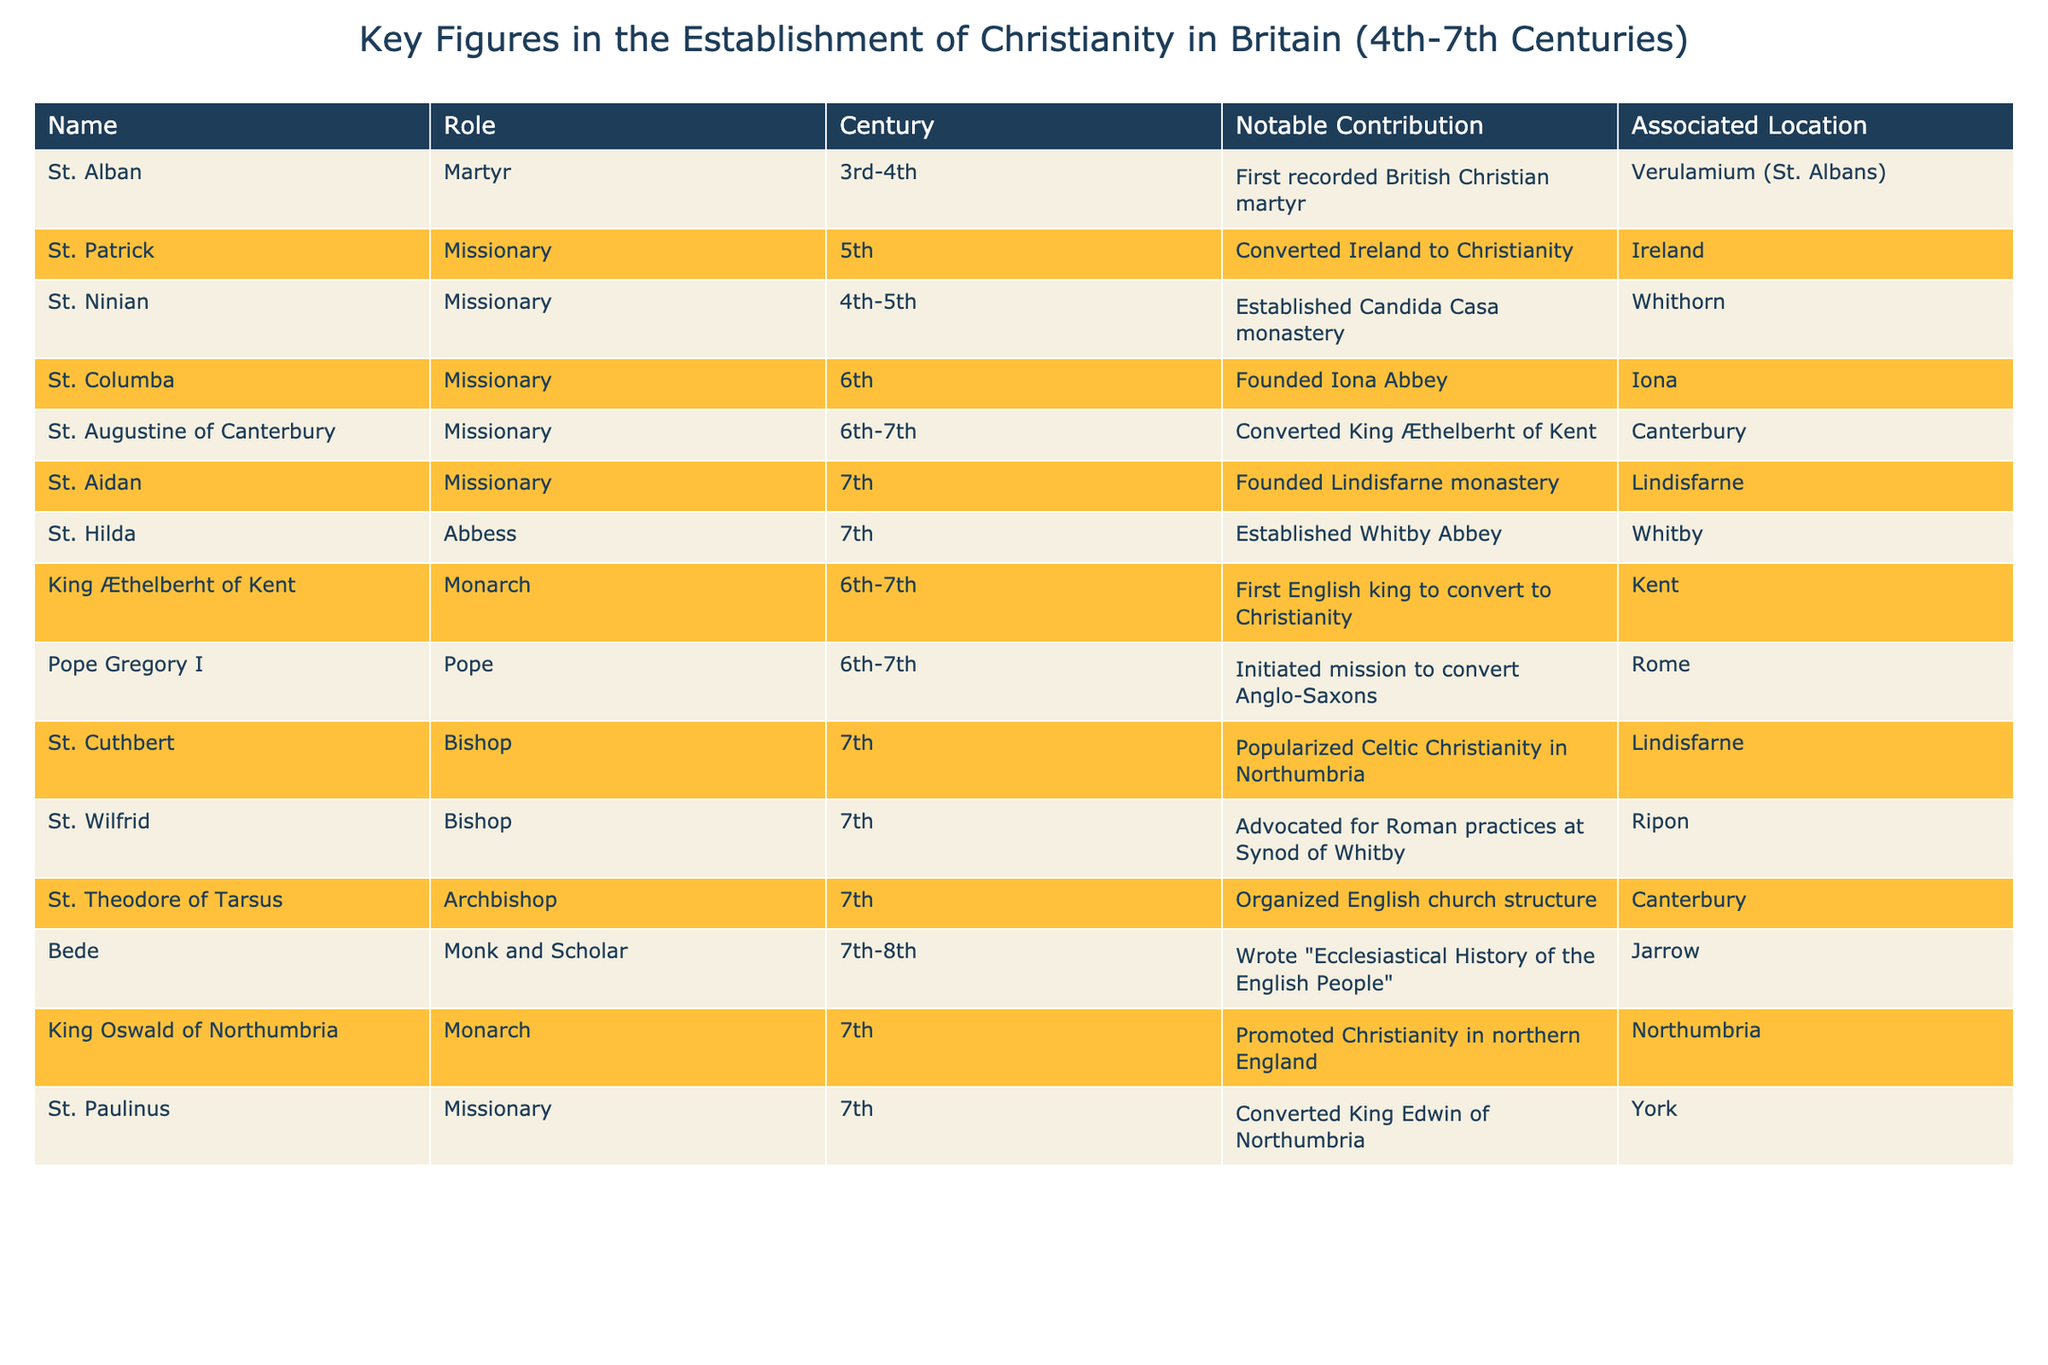What was St. Alban's notable contribution? St. Alban is recorded in the table as the first British Christian martyr. This specific information can be found in the "Notable Contribution" column associated with his name.
Answer: First recorded British Christian martyr Which century did St. Augustine of Canterbury contribute to the establishment of Christianity in Britain? By referencing the "Century" column in the table next to St. Augustine of Canterbury's name, we find that his contributions occurred during the 6th-7th centuries.
Answer: 6th-7th century How many figures in the table were involved in missionary work? By reviewing the roles listed in the table, we count those identified as "Missionary." There are 6 individuals fulfilling this role: St. Patrick, St. Ninian, St. Columba, St. Augustine of Canterbury, St. Aidan, and St. Paulinus.
Answer: 6 Did any of the key figures have a significant role in converting a king to Christianity? By examining the data, we find that both St. Augustine of Canterbury and St. Paulinus are noted for converting kings (King Æthelberht of Kent and King Edwin of Northumbria, respectively). Therefore, the answer is yes.
Answer: Yes Who was the first English king to convert to Christianity? Looking at the "Notable Contribution" for King Æthelberht of Kent in the table, it states that he was the first English king to convert to Christianity, indicating his significance in this matter.
Answer: King Æthelberht of Kent What is the average century of the key figures listed in the table? To find the average century, we convert the centuries into numerical values (taking 6th-7th as 6.5 and averaging all figures). The contributions range from the 3rd-4th to 6th-7th centuries, and calculating their average gives us approximately 6.
Answer: 6 Which location is associated with both St. Aidan and St. Cuthbert? By inspecting the table, we note that both St. Aidan and St. Cuthbert are associated with the location of Lindisfarne. This means they share the same region.
Answer: Lindisfarne How did St. Hilda's role differ from that of St. Wilfrid in the establishment of Christianity? St. Hilda is noted as an Abbess who established Whitby Abbey, whereas St. Wilfrid was a bishop who advocated for Roman practices at the Synod of Whitby. This indicates different focuses in their contributions—establishment versus advocacy for a specific church practice.
Answer: Different roles: establishment vs advocacy 